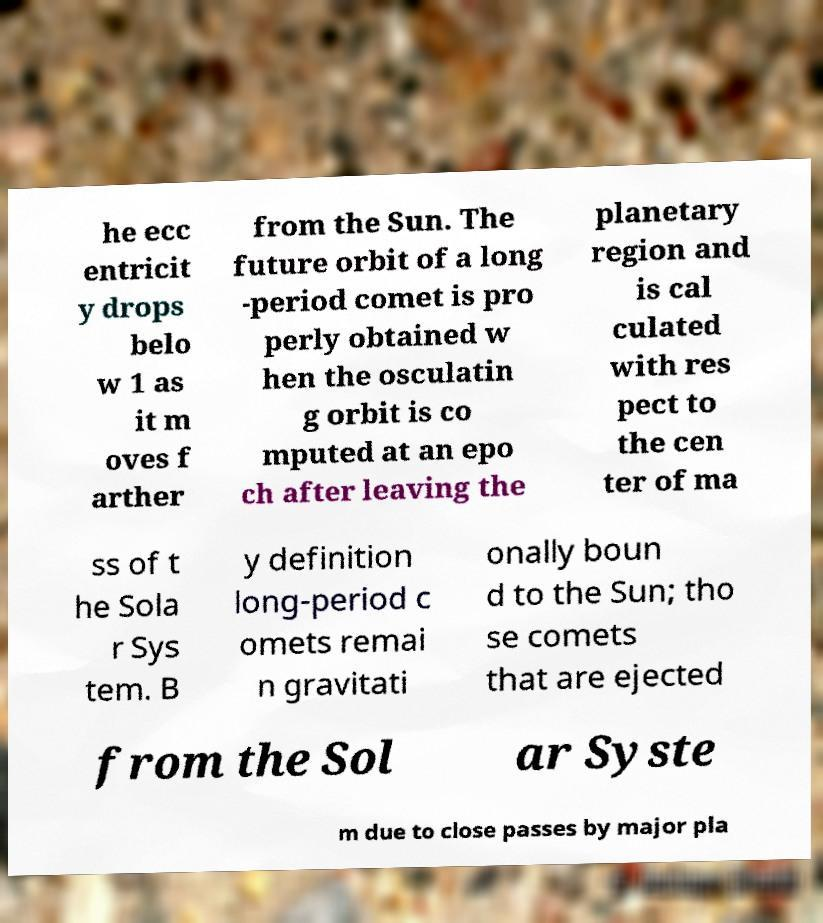Can you accurately transcribe the text from the provided image for me? he ecc entricit y drops belo w 1 as it m oves f arther from the Sun. The future orbit of a long -period comet is pro perly obtained w hen the osculatin g orbit is co mputed at an epo ch after leaving the planetary region and is cal culated with res pect to the cen ter of ma ss of t he Sola r Sys tem. B y definition long-period c omets remai n gravitati onally boun d to the Sun; tho se comets that are ejected from the Sol ar Syste m due to close passes by major pla 